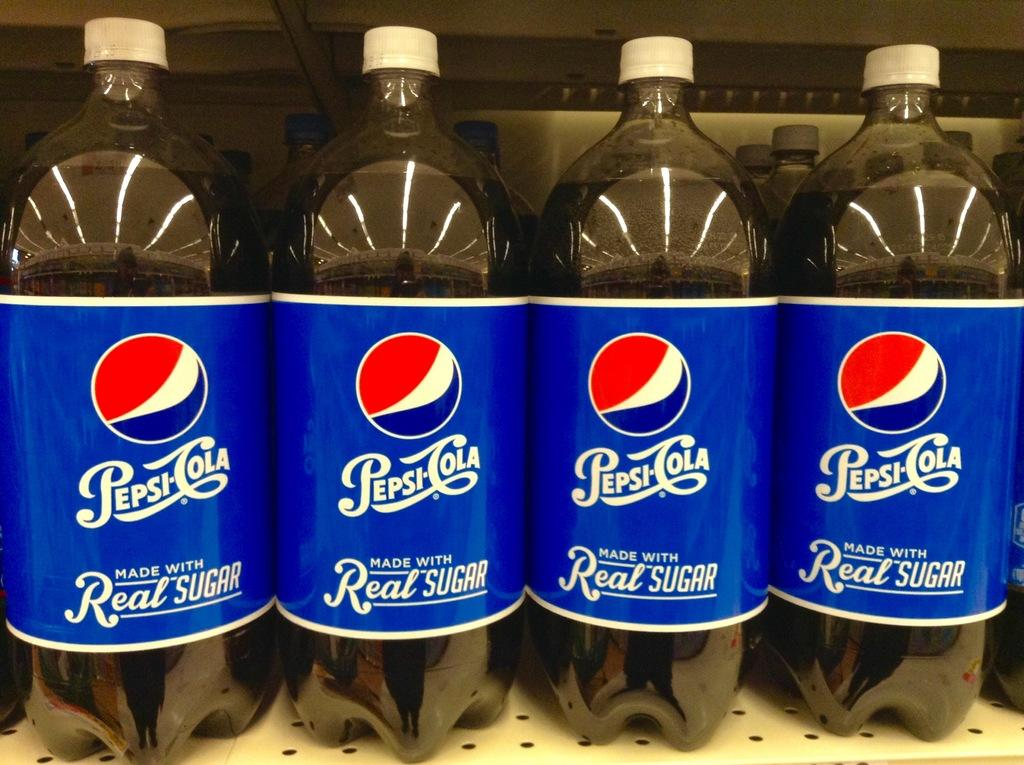What is contained in the bottles that are visible in the image? There are bottles with a drink in the image. What else can be seen on the wall in the image? There is a poster in the image. What type of furniture or storage item is present in the image? There is a rack in the image. What industry is depicted in the history of the hot drink in the image? There is no reference to any industry, history, or hot drink in the image. 